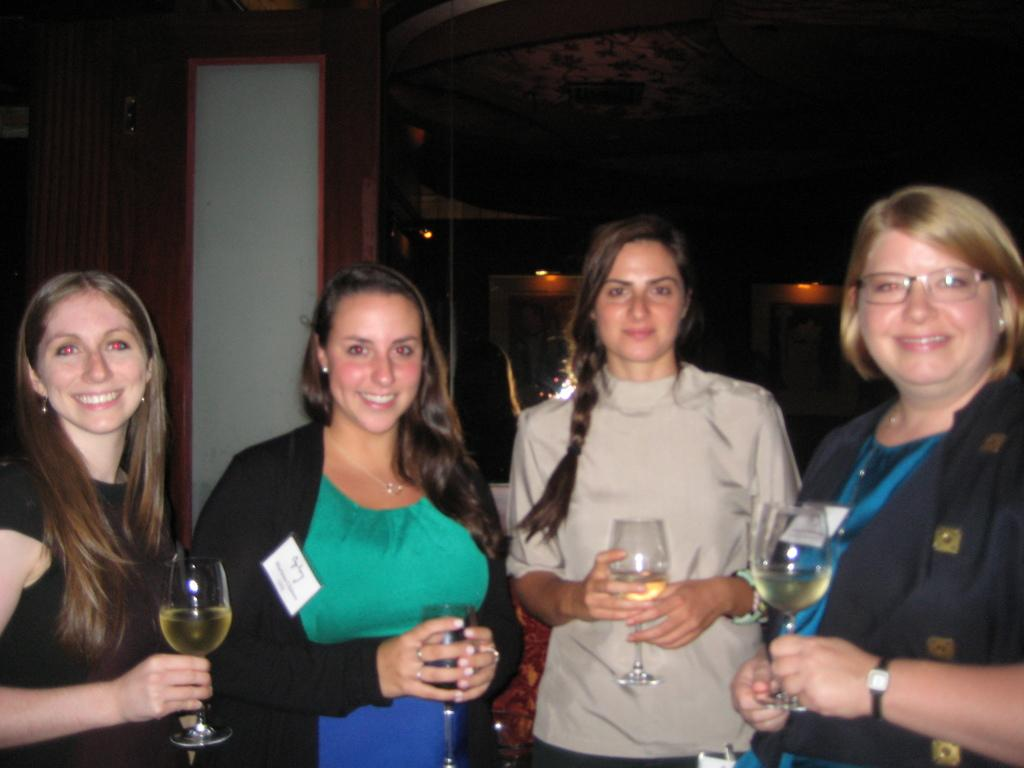How many people are in the image? There are four ladies in the image. What are the ladies holding in their hands? Each lady is holding a glass. What is inside the glasses? The glasses contain wine. Can you see a ring on any of the ladies' fingers in the image? There is no mention of a ring in the provided facts, so we cannot determine if any of the ladies are wearing a ring. 